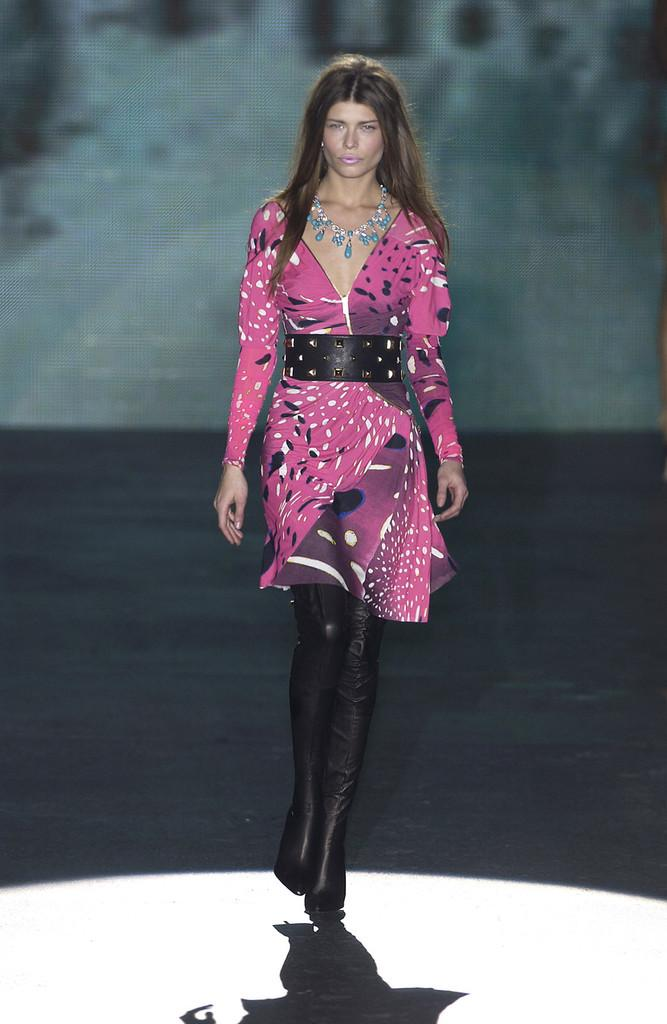What is the main subject of the image? The main subject of the image is a woman. What is the woman doing in the image? The woman is walking on the floor in the image. Where is the woman located in the image? The woman is in the center of the image. What type of coil can be seen in the image? There is no coil present in the image. What kind of machine is the woman operating in the image? There is no machine present in the image; the woman is simply walking on the floor. 